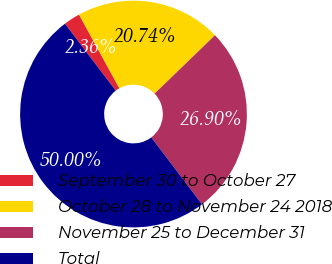<chart> <loc_0><loc_0><loc_500><loc_500><pie_chart><fcel>September 30 to October 27<fcel>October 28 to November 24 2018<fcel>November 25 to December 31<fcel>Total<nl><fcel>2.36%<fcel>20.74%<fcel>26.9%<fcel>50.0%<nl></chart> 